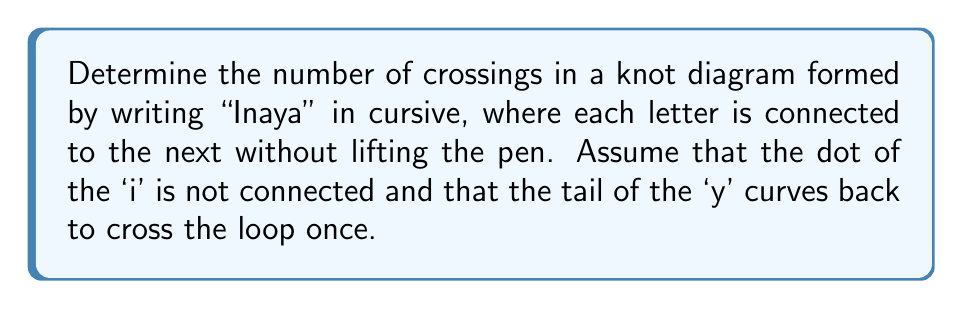Teach me how to tackle this problem. Let's analyze this step-by-step:

1) First, let's consider each letter individually:
   - 'I': No crossings
   - 'n': No crossings
   - 'a': One crossing where the loop closes
   - 'y': One crossing where the tail intersects the loop
   - 'a': One crossing where the loop closes

2) Now, let's consider the connections between letters:
   - 'I' to 'n': No additional crossings
   - 'n' to 'a': No additional crossings
   - 'a' to 'y': One additional crossing where the connection line intersects the loop of 'a'
   - 'y' to 'a': One additional crossing where the connection line intersects the tail of 'y'

3) Let's sum up the crossings:
   $$ \text{Total crossings} = 1 + 1 + 1 + 1 + 1 = 5 $$

   Where the crossings are:
   - One in the first 'a'
   - One in the 'y'
   - One in the second 'a'
   - One between 'a' and 'y'
   - One between 'y' and 'a'

Therefore, the knot diagram of "Inaya" written in cursive would have 5 crossings.
Answer: 5 crossings 